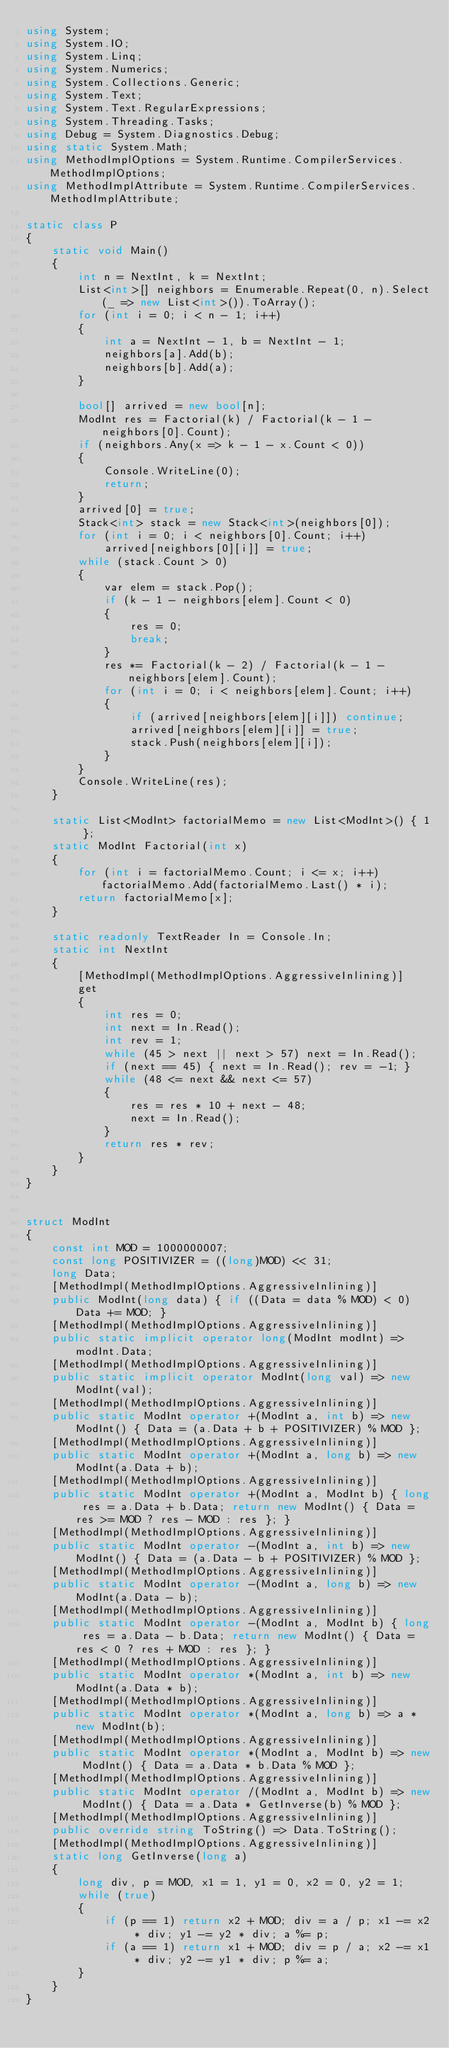<code> <loc_0><loc_0><loc_500><loc_500><_C#_>using System;
using System.IO;
using System.Linq;
using System.Numerics;
using System.Collections.Generic;
using System.Text;
using System.Text.RegularExpressions;
using System.Threading.Tasks;
using Debug = System.Diagnostics.Debug;
using static System.Math;
using MethodImplOptions = System.Runtime.CompilerServices.MethodImplOptions;
using MethodImplAttribute = System.Runtime.CompilerServices.MethodImplAttribute;

static class P
{
    static void Main()
    {
        int n = NextInt, k = NextInt;
        List<int>[] neighbors = Enumerable.Repeat(0, n).Select(_ => new List<int>()).ToArray();
        for (int i = 0; i < n - 1; i++)
        {
            int a = NextInt - 1, b = NextInt - 1;
            neighbors[a].Add(b);
            neighbors[b].Add(a);
        }

        bool[] arrived = new bool[n];
        ModInt res = Factorial(k) / Factorial(k - 1 - neighbors[0].Count);
        if (neighbors.Any(x => k - 1 - x.Count < 0))
        {
            Console.WriteLine(0);
            return;
        }
        arrived[0] = true;
        Stack<int> stack = new Stack<int>(neighbors[0]);
        for (int i = 0; i < neighbors[0].Count; i++)
            arrived[neighbors[0][i]] = true;
        while (stack.Count > 0)
        {
            var elem = stack.Pop();
            if (k - 1 - neighbors[elem].Count < 0)
            {
                res = 0;
                break;
            }
            res *= Factorial(k - 2) / Factorial(k - 1 - neighbors[elem].Count);
            for (int i = 0; i < neighbors[elem].Count; i++)
            {
                if (arrived[neighbors[elem][i]]) continue;
                arrived[neighbors[elem][i]] = true;
                stack.Push(neighbors[elem][i]);
            }
        }
        Console.WriteLine(res);
    }

    static List<ModInt> factorialMemo = new List<ModInt>() { 1 };
    static ModInt Factorial(int x)
    {
        for (int i = factorialMemo.Count; i <= x; i++) factorialMemo.Add(factorialMemo.Last() * i);
        return factorialMemo[x];
    }

    static readonly TextReader In = Console.In;
    static int NextInt
    {
        [MethodImpl(MethodImplOptions.AggressiveInlining)]
        get
        {
            int res = 0;
            int next = In.Read();
            int rev = 1;
            while (45 > next || next > 57) next = In.Read();
            if (next == 45) { next = In.Read(); rev = -1; }
            while (48 <= next && next <= 57)
            {
                res = res * 10 + next - 48;
                next = In.Read();
            }
            return res * rev;
        }
    }
}


struct ModInt
{
    const int MOD = 1000000007;
    const long POSITIVIZER = ((long)MOD) << 31;
    long Data;
    [MethodImpl(MethodImplOptions.AggressiveInlining)]
    public ModInt(long data) { if ((Data = data % MOD) < 0) Data += MOD; }
    [MethodImpl(MethodImplOptions.AggressiveInlining)]
    public static implicit operator long(ModInt modInt) => modInt.Data;
    [MethodImpl(MethodImplOptions.AggressiveInlining)]
    public static implicit operator ModInt(long val) => new ModInt(val);
    [MethodImpl(MethodImplOptions.AggressiveInlining)]
    public static ModInt operator +(ModInt a, int b) => new ModInt() { Data = (a.Data + b + POSITIVIZER) % MOD };
    [MethodImpl(MethodImplOptions.AggressiveInlining)]
    public static ModInt operator +(ModInt a, long b) => new ModInt(a.Data + b);
    [MethodImpl(MethodImplOptions.AggressiveInlining)]
    public static ModInt operator +(ModInt a, ModInt b) { long res = a.Data + b.Data; return new ModInt() { Data = res >= MOD ? res - MOD : res }; }
    [MethodImpl(MethodImplOptions.AggressiveInlining)]
    public static ModInt operator -(ModInt a, int b) => new ModInt() { Data = (a.Data - b + POSITIVIZER) % MOD };
    [MethodImpl(MethodImplOptions.AggressiveInlining)]
    public static ModInt operator -(ModInt a, long b) => new ModInt(a.Data - b);
    [MethodImpl(MethodImplOptions.AggressiveInlining)]
    public static ModInt operator -(ModInt a, ModInt b) { long res = a.Data - b.Data; return new ModInt() { Data = res < 0 ? res + MOD : res }; }
    [MethodImpl(MethodImplOptions.AggressiveInlining)]
    public static ModInt operator *(ModInt a, int b) => new ModInt(a.Data * b);
    [MethodImpl(MethodImplOptions.AggressiveInlining)]
    public static ModInt operator *(ModInt a, long b) => a * new ModInt(b);
    [MethodImpl(MethodImplOptions.AggressiveInlining)]
    public static ModInt operator *(ModInt a, ModInt b) => new ModInt() { Data = a.Data * b.Data % MOD };
    [MethodImpl(MethodImplOptions.AggressiveInlining)]
    public static ModInt operator /(ModInt a, ModInt b) => new ModInt() { Data = a.Data * GetInverse(b) % MOD };
    [MethodImpl(MethodImplOptions.AggressiveInlining)]
    public override string ToString() => Data.ToString();
    [MethodImpl(MethodImplOptions.AggressiveInlining)]
    static long GetInverse(long a)
    {
        long div, p = MOD, x1 = 1, y1 = 0, x2 = 0, y2 = 1;
        while (true)
        {
            if (p == 1) return x2 + MOD; div = a / p; x1 -= x2 * div; y1 -= y2 * div; a %= p;
            if (a == 1) return x1 + MOD; div = p / a; x2 -= x1 * div; y2 -= y1 * div; p %= a;
        }
    }
}
</code> 